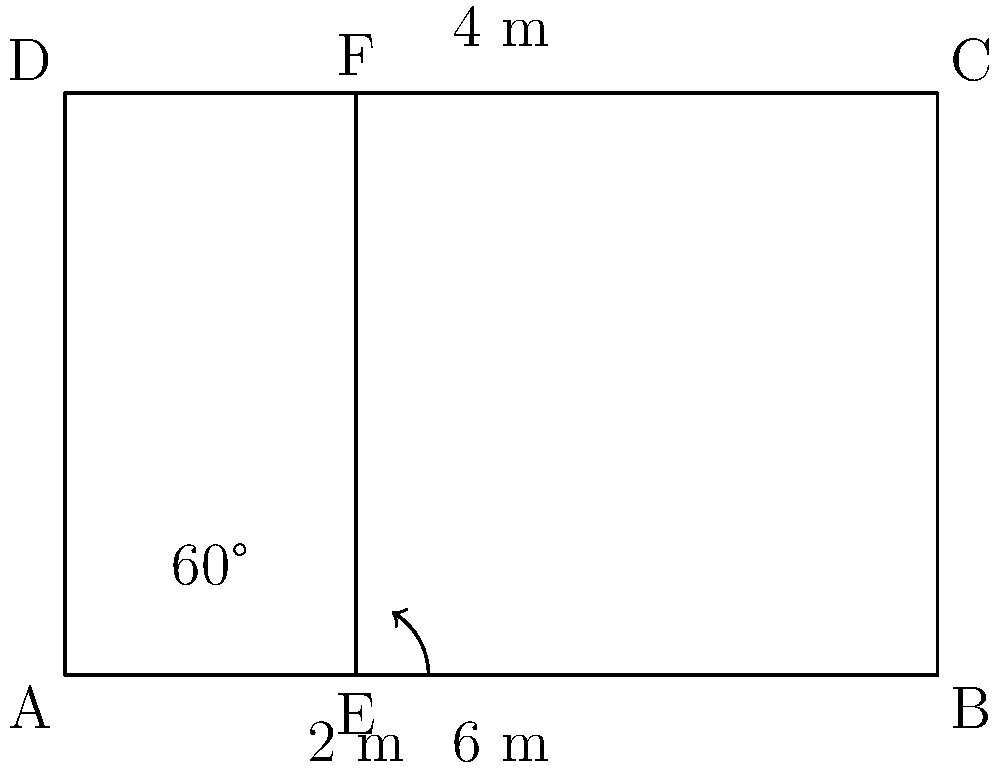In designing a new shelving unit for emergency supplies, you're considering an angled shelf to improve accessibility. The diagram shows a side view of the proposed unit. If the total width is 6 m, the height is 4 m, and the angled shelf is positioned 2 m from the left side with a 60° angle, what is the length of the angled shelf to the nearest centimeter? To find the length of the angled shelf, we can follow these steps:

1) First, we need to identify the right triangle formed by the angled shelf. The base of this triangle is 2 m (from point E to B), and we know one of its angles is 60°.

2) In a 60°-30°-90° triangle, the ratio of sides is 1 : $\sqrt{3}$ : 2.

3) The shortest side (opposite to 30°) is 2 m in our case. So, we can set up the ratio:

   $2 : x : 4$

   Where $x$ is the length of the angled shelf we're trying to find.

4) From this ratio, we can derive:
   $x = 2\sqrt{3}$

5) To calculate this:
   $2\sqrt{3} \approx 2 * 1.7321 = 3.4641$ m

6) Rounding to the nearest centimeter:
   3.4641 m = 346.41 cm ≈ 346 cm

Therefore, the length of the angled shelf is approximately 346 cm.
Answer: 346 cm 